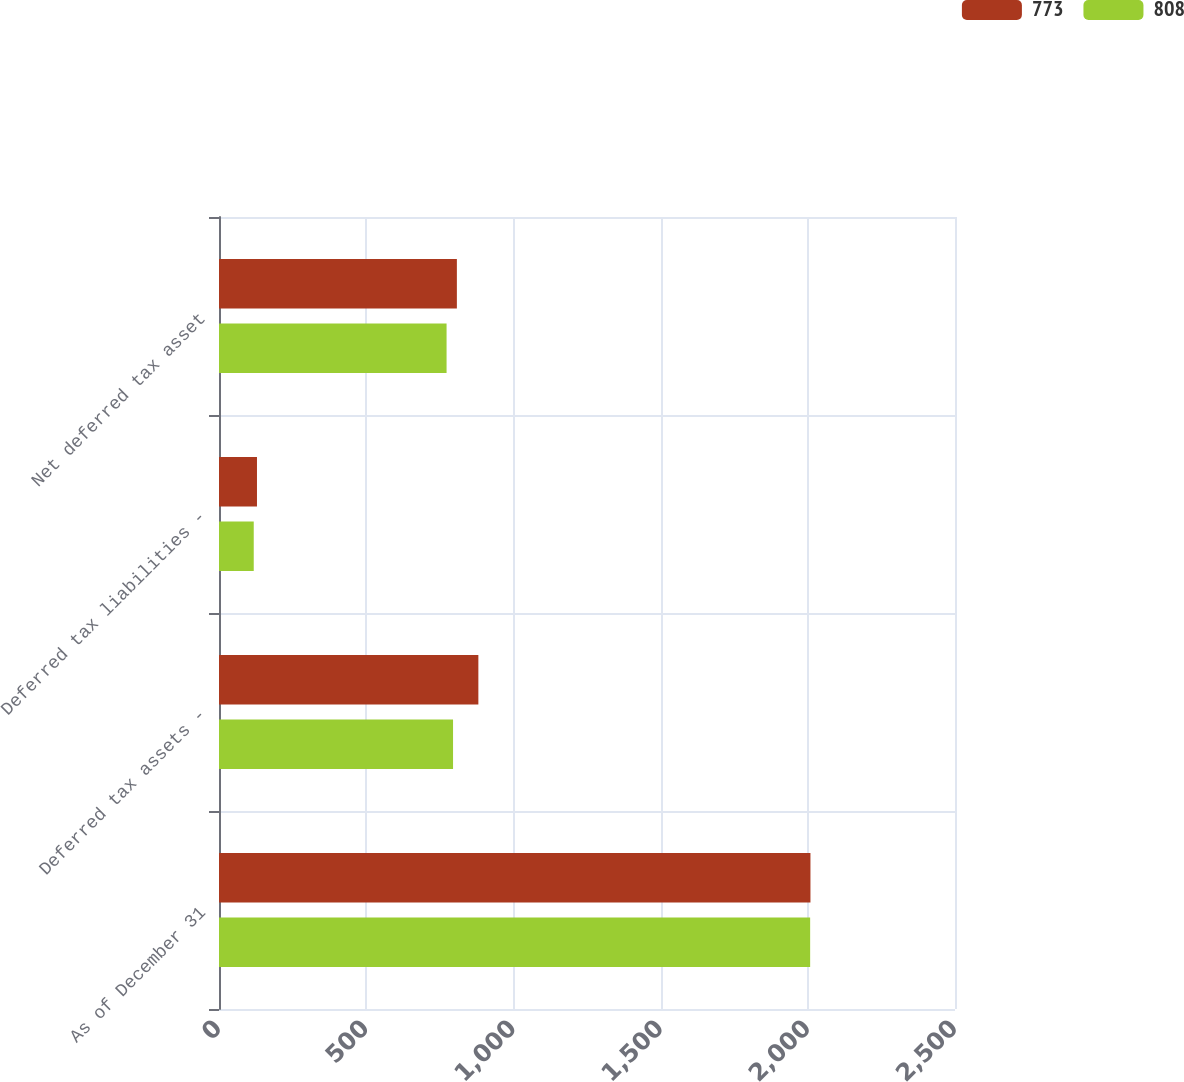Convert chart. <chart><loc_0><loc_0><loc_500><loc_500><stacked_bar_chart><ecel><fcel>As of December 31<fcel>Deferred tax assets -<fcel>Deferred tax liabilities -<fcel>Net deferred tax asset<nl><fcel>773<fcel>2009<fcel>881<fcel>129<fcel>808<nl><fcel>808<fcel>2008<fcel>795<fcel>118<fcel>773<nl></chart> 